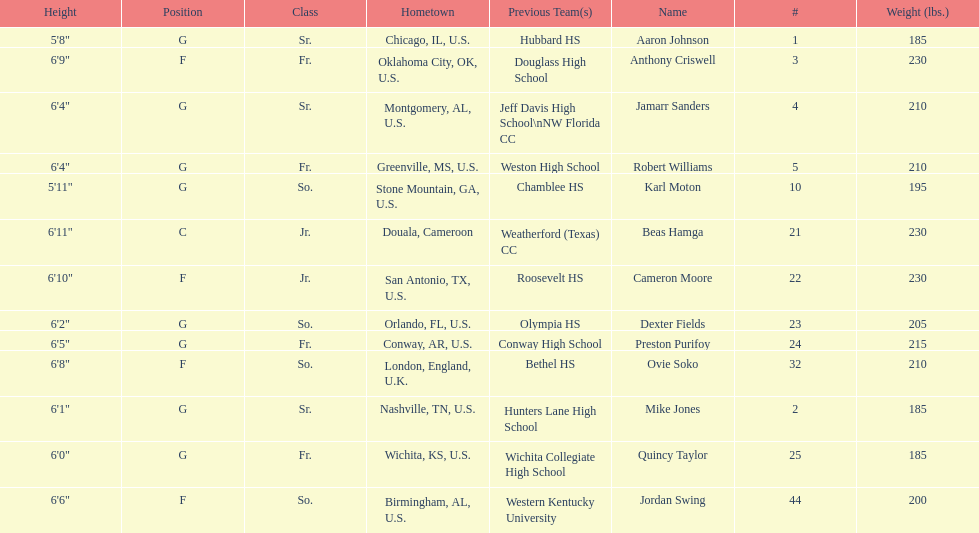How many players were on the 2010-11 uab blazers men's basketball team? 13. 